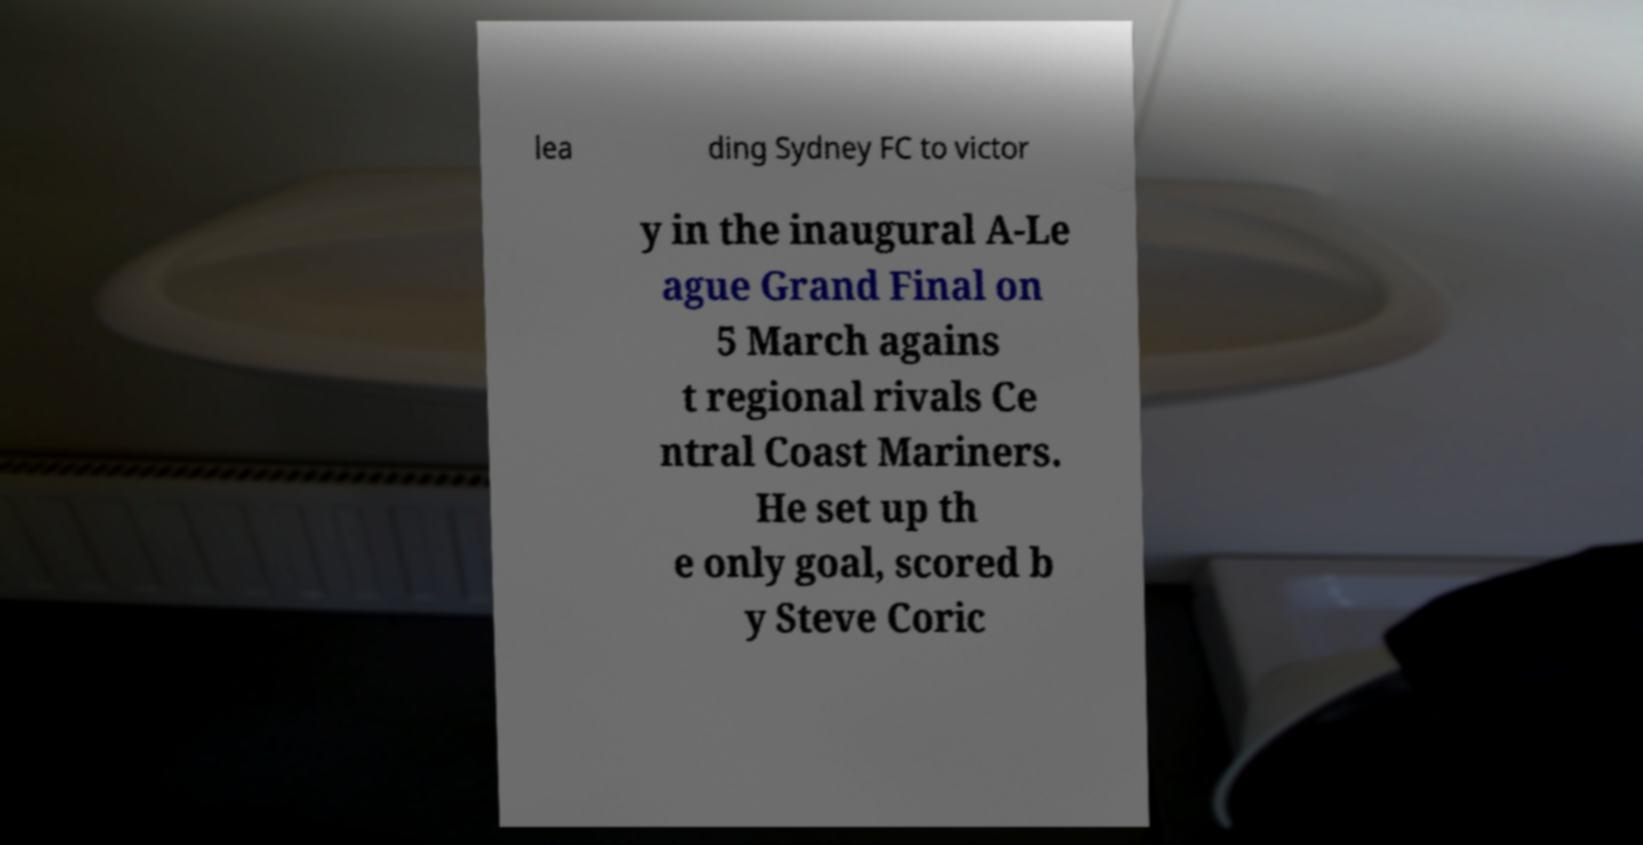Please identify and transcribe the text found in this image. lea ding Sydney FC to victor y in the inaugural A-Le ague Grand Final on 5 March agains t regional rivals Ce ntral Coast Mariners. He set up th e only goal, scored b y Steve Coric 